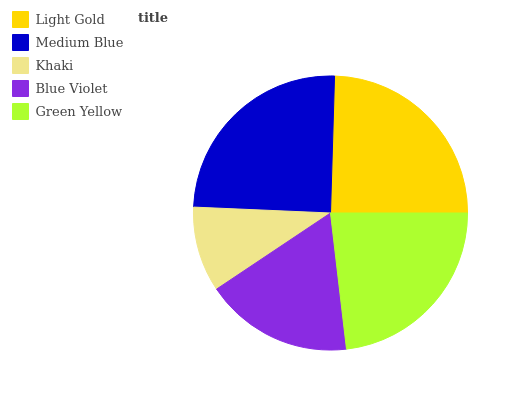Is Khaki the minimum?
Answer yes or no. Yes. Is Medium Blue the maximum?
Answer yes or no. Yes. Is Medium Blue the minimum?
Answer yes or no. No. Is Khaki the maximum?
Answer yes or no. No. Is Medium Blue greater than Khaki?
Answer yes or no. Yes. Is Khaki less than Medium Blue?
Answer yes or no. Yes. Is Khaki greater than Medium Blue?
Answer yes or no. No. Is Medium Blue less than Khaki?
Answer yes or no. No. Is Green Yellow the high median?
Answer yes or no. Yes. Is Green Yellow the low median?
Answer yes or no. Yes. Is Blue Violet the high median?
Answer yes or no. No. Is Light Gold the low median?
Answer yes or no. No. 